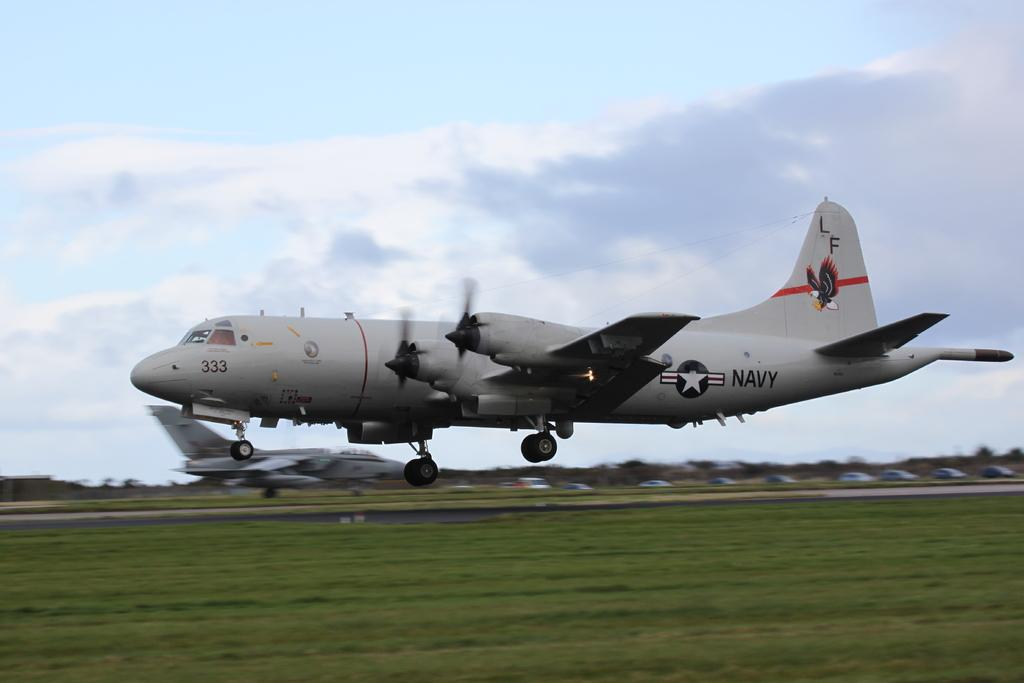<image>
Present a compact description of the photo's key features. A Navy aircraft with the numbers 333 on it landing on a runway 